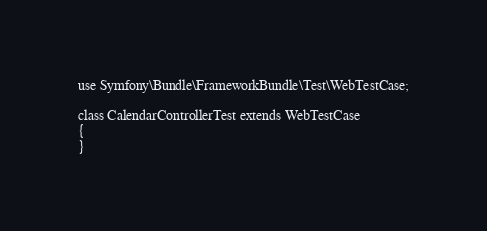Convert code to text. <code><loc_0><loc_0><loc_500><loc_500><_PHP_>
use Symfony\Bundle\FrameworkBundle\Test\WebTestCase;

class CalendarControllerTest extends WebTestCase
{
}
</code> 